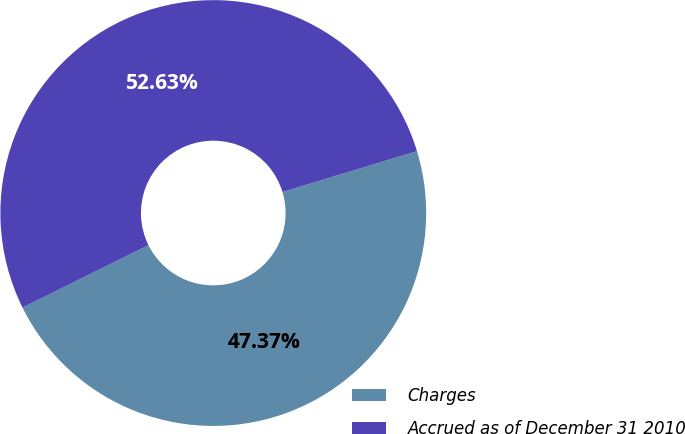Convert chart to OTSL. <chart><loc_0><loc_0><loc_500><loc_500><pie_chart><fcel>Charges<fcel>Accrued as of December 31 2010<nl><fcel>47.37%<fcel>52.63%<nl></chart> 